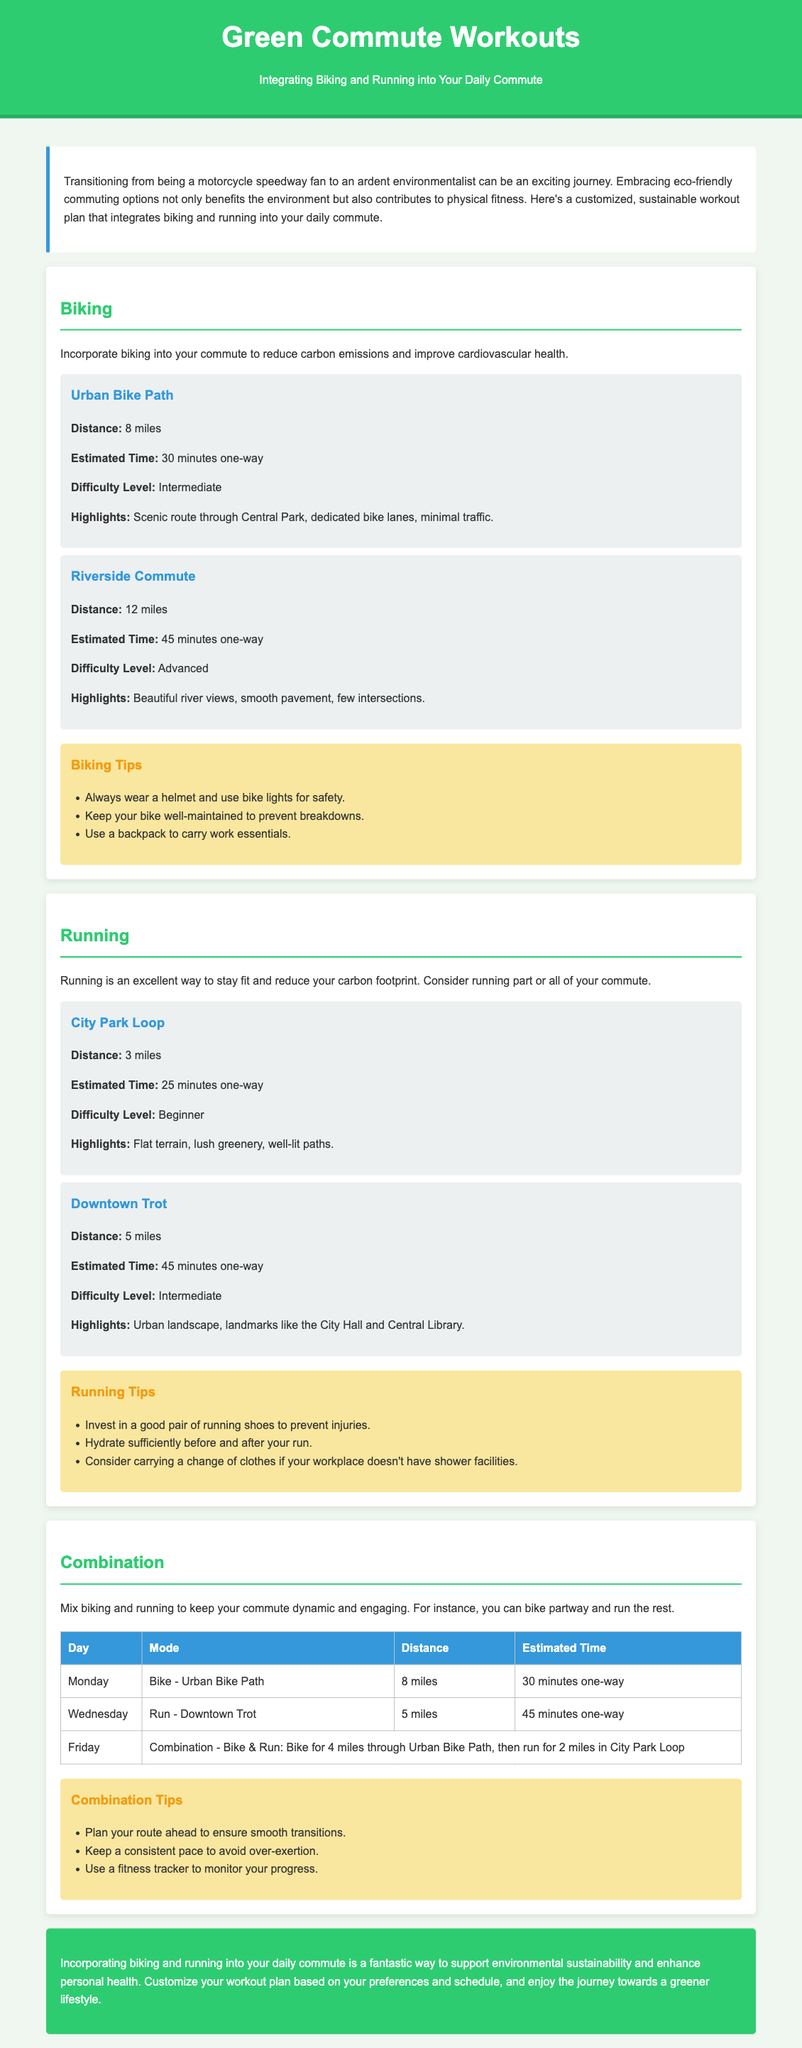What is the distance of the Urban Bike Path? The Urban Bike Path has a specified distance of 8 miles.
Answer: 8 miles What is the estimated time for the Riverside Commute? The Riverside Commute has an estimated time of 45 minutes one-way.
Answer: 45 minutes What is the difficulty level of the City Park Loop? The City Park Loop is categorized as a Beginner level.
Answer: Beginner On which day is the Downtown Trot scheduled in the combination plan? The Downtown Trot is scheduled on Wednesday in the combination plan.
Answer: Wednesday What safety equipment is recommended for biking? The document recommends wearing a helmet and using bike lights for safety.
Answer: Helmet and bike lights What should you consider carrying if your workplace lacks shower facilities? You should consider carrying a change of clothes if your workplace doesn't have shower facilities.
Answer: Change of clothes What is the highlight of the Riverside Commute? The highlight of the Riverside Commute is beautiful river views.
Answer: Beautiful river views What is a tip for effectively mixing biking and running during the commute? Plan your route ahead to ensure smooth transitions when mixing biking and running.
Answer: Plan your route ahead How many miles does the combination workout cover on Friday? The combination workout on Friday covers a total of 6 miles (4 miles biking + 2 miles running).
Answer: 6 miles 